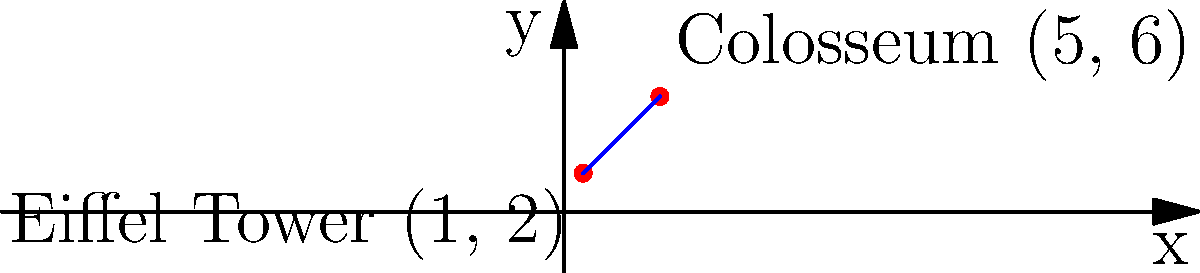On a coordinate system representing popular European tourist attractions, the Eiffel Tower is located at (1, 2) and the Colosseum is at (5, 6). Calculate the slope of the line connecting these two landmarks. How would this help in planning an economical trip between these destinations? To calculate the slope of the line connecting two points, we use the formula:

$$ \text{Slope} = \frac{y_2 - y_1}{x_2 - x_1} $$

Where $(x_1, y_1)$ is the first point and $(x_2, y_2)$ is the second point.

1. Identify the coordinates:
   Eiffel Tower: $(x_1, y_1) = (1, 2)$
   Colosseum: $(x_2, y_2) = (5, 6)$

2. Substitute these values into the slope formula:

   $$ \text{Slope} = \frac{6 - 2}{5 - 1} = \frac{4}{4} = 1 $$

3. Simplify the fraction to get the final answer.

Understanding the slope can help in planning an economical trip by:
- Visualizing the direct path between attractions
- Estimating travel time and distance
- Potentially identifying other attractions along the same route
- Helping to group nearby attractions for efficient sightseeing

This approach can lead to savings on transportation costs and maximize the number of attractions visited in a limited time.
Answer: $1$ 